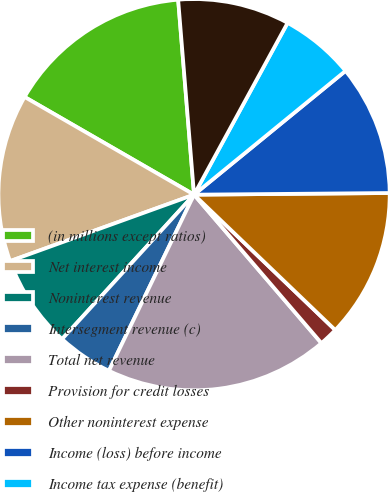<chart> <loc_0><loc_0><loc_500><loc_500><pie_chart><fcel>(in millions except ratios)<fcel>Net interest income<fcel>Noninterest revenue<fcel>Intersegment revenue (c)<fcel>Total net revenue<fcel>Provision for credit losses<fcel>Other noninterest expense<fcel>Income (loss) before income<fcel>Income tax expense (benefit)<fcel>Net income (loss)<nl><fcel>15.38%<fcel>13.84%<fcel>7.7%<fcel>4.62%<fcel>18.45%<fcel>1.55%<fcel>12.3%<fcel>10.77%<fcel>6.16%<fcel>9.23%<nl></chart> 